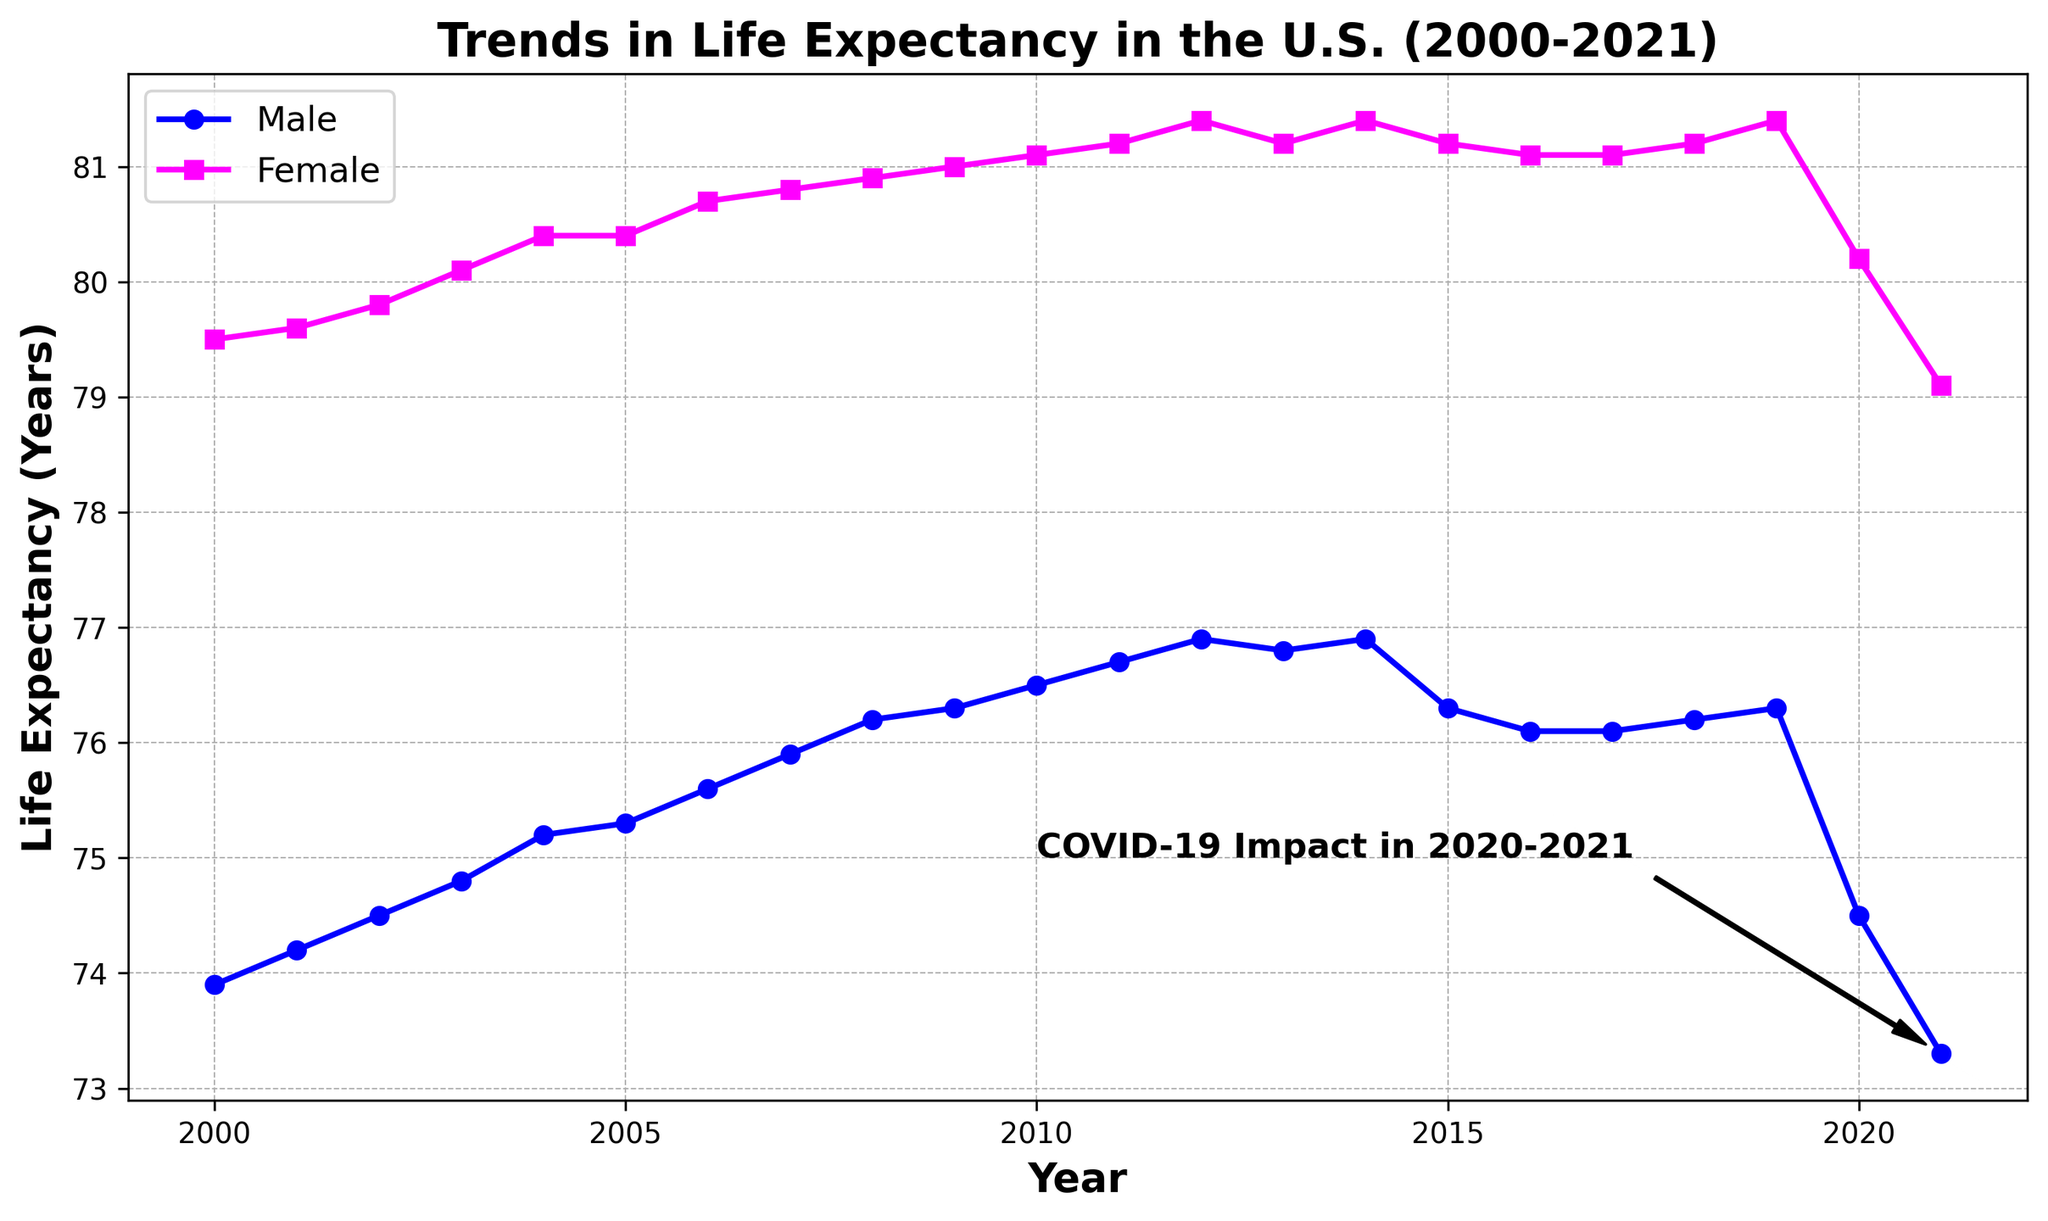When did the life expectancy for males peak during the given time frame? To find when the male life expectancy was highest, look for the maximum value on the male line (blue) and track it to the corresponding year on the x-axis. The highest point is at 2014, slightly dropping in succeeding years.
Answer: 2014 What is the difference in life expectancy between males and females in 2005? Find the corresponding points for male and female life expectancy on the y-axis in 2005, then subtract the male value from the female value. For 2005, male life expectancy is 75.3 years and female is 80.4 years. The difference is 80.4 - 75.3 = 5.1 years.
Answer: 5.1 years Which gender had a steeper decline in life expectancy from 2019 to 2021? Compare the slopes of the male (blue) and female (magenta) lines between 2019 and 2021. The male life expectancy drops from 76.3 in 2019 to 73.3 in 2021, a difference of 3.0 years. The female life expectancy drops from 81.4 in 2019 to 79.1 in 2021, a difference of 2.3 years. Therefore, the male had a steeper decline.
Answer: Male By how much did the female life expectancy increase from 2000 to 2014? Check the data points for female life expectancy in 2000 and 2014, and subtract the value in 2000 from the value in 2014. In 2000, it was 79.5 years and in 2014, it was 81.4 years. The increase is 81.4 - 79.5 = 1.9 years.
Answer: 1.9 years In which year did male and female life expectancies experience a notable dip due to COVID-19? Look for the annotation pointing out "COVID-19 Impact in 2020-2021." Both male and female life expectancy lines show a visible dip during these years.
Answer: 2020-2021 What was the average life expectancy for males over the entire time period? Sum up the life expectancy values for males from 2000 to 2021, then divide by the total number of years, which is 22. (73.9 + 74.2 + 74.5 + 74.8 + 75.2 + 75.3 + 75.6 + 75.9 + 76.2 + 76.3 + 76.5 + 76.7 + 76.9 + 76.8 + 76.9 + 76.3 + 76.1 + 76.1 + 76.2 + 76.3 + 74.5 + 73.3) / 22 = 75.70
Answer: 75.7 years How many years did life expectancy for females remain constant at the same value? Check the female data line for any flat sections. Female life expectancy remained constant at 80.4 years during 2004 and 2005, and 81.2 years during 2011 and 2013, and again from 2015 to 2017. In total, life expectancy for females was constant for 3 (2004, 2005) + 2 (2011, 2013) + 3 (2015-2017) = 8 years.
Answer: 8 years 